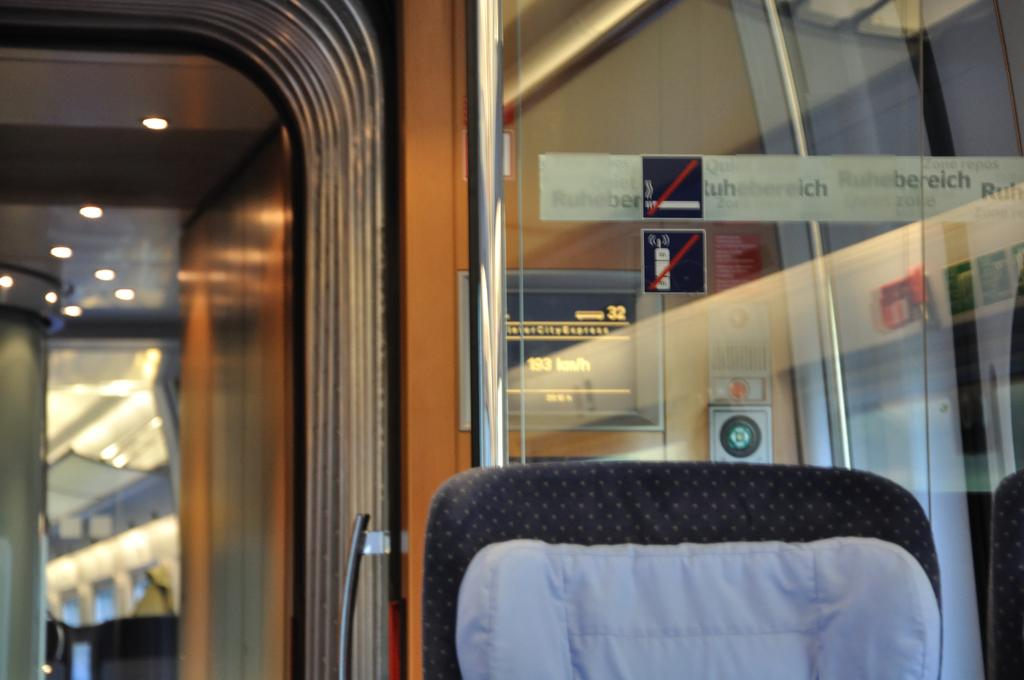What type of furniture is present in the image? There is a chair in the image. Where is the chair located in the image? The chair is at the bottom side of the image. What other object can be seen in the image? There is a door in the image. On which side of the image is the door located? The door is on the left side of the image. What type of secretary is sitting on the sidewalk in the image? There is no secretary or sidewalk present in the image; it only features a chair and a door. 